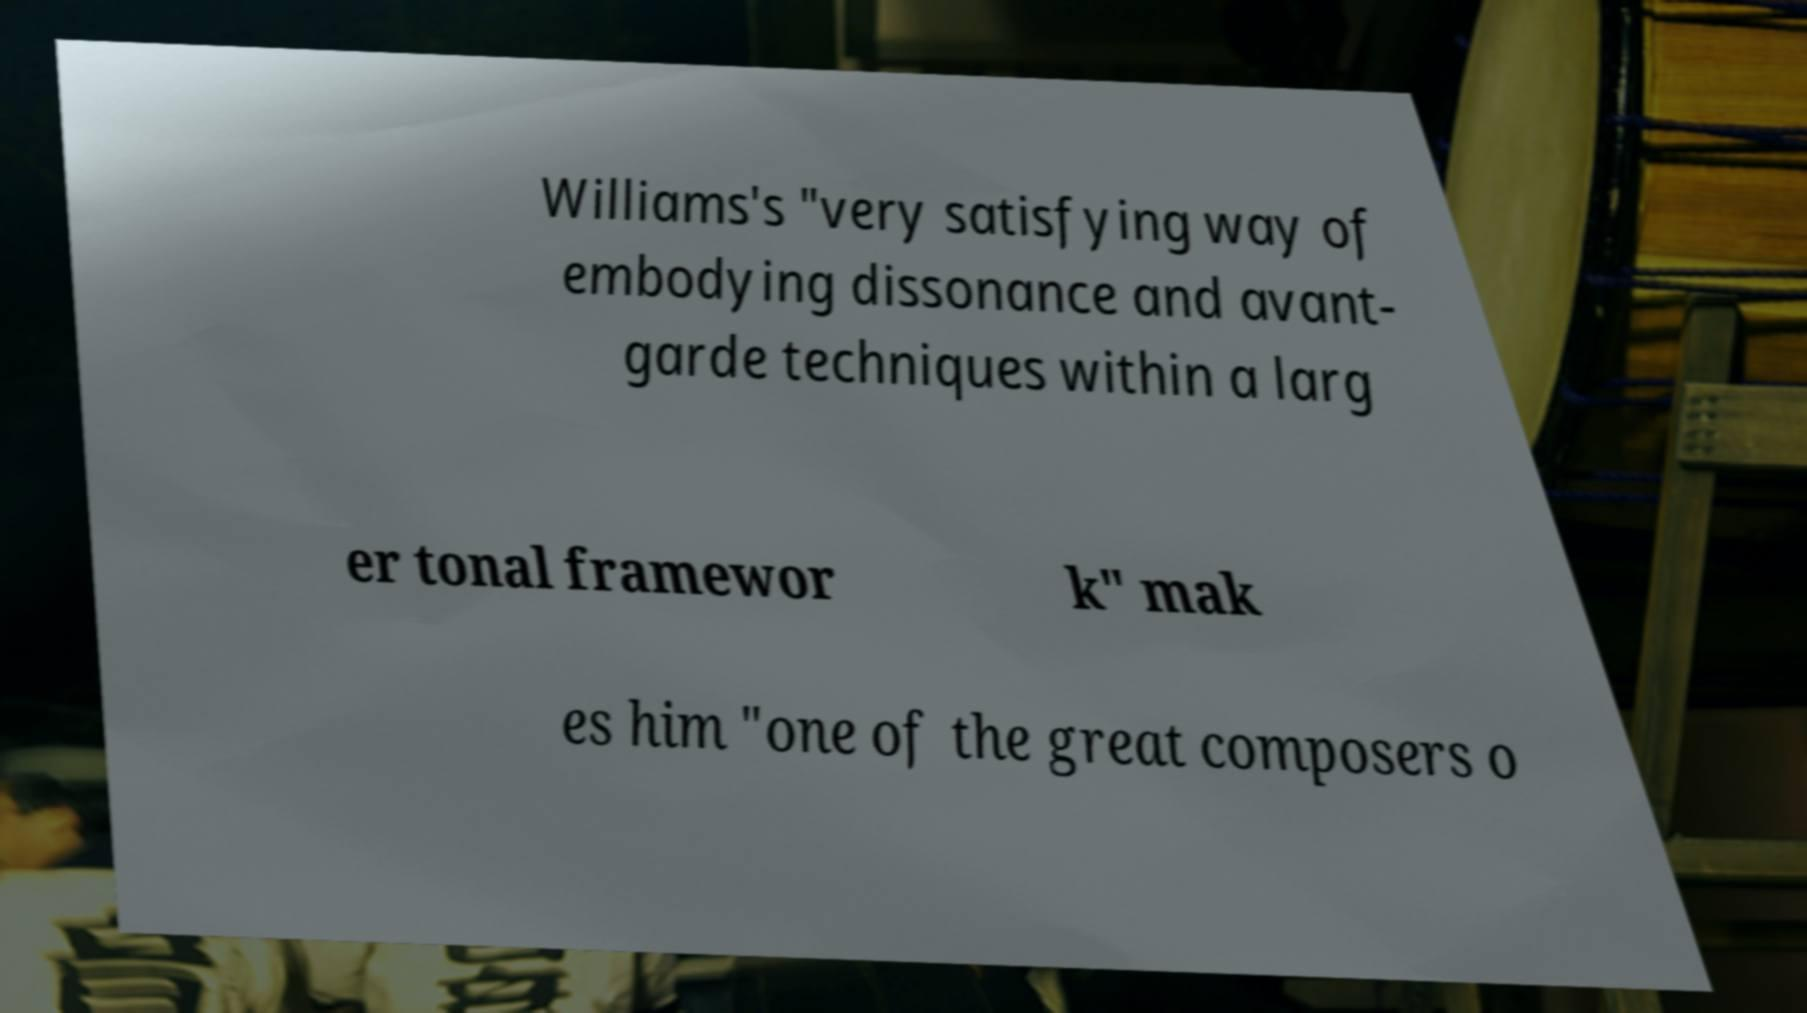Could you assist in decoding the text presented in this image and type it out clearly? Williams's "very satisfying way of embodying dissonance and avant- garde techniques within a larg er tonal framewor k" mak es him "one of the great composers o 